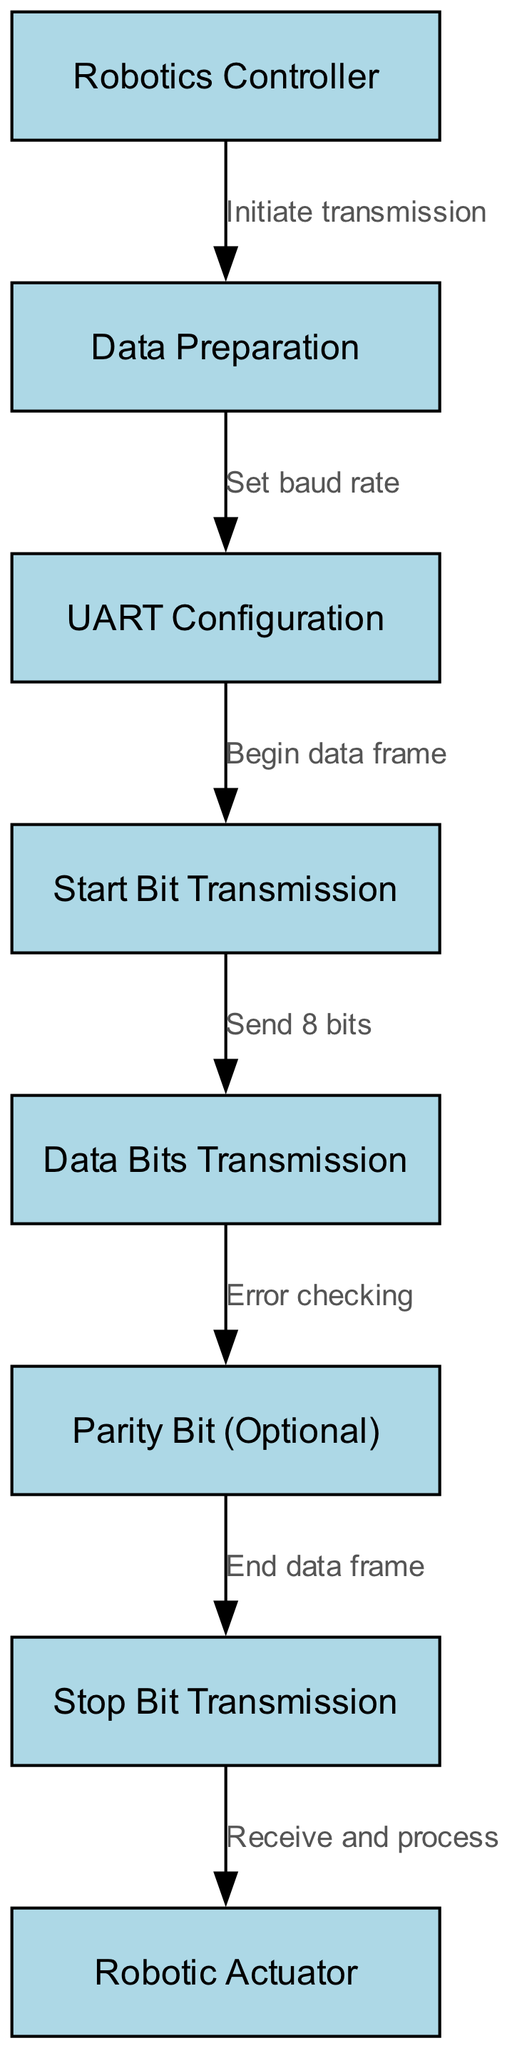What is the starting point of the transmission process? The starting point of the transmission process is the "Robotics Controller," which initiates the communication sequence.
Answer: Robotics Controller How many nodes are there in the diagram? There are a total of eight nodes represented in the diagram that outline the steps of the data transmission process.
Answer: Eight What does the "Data Preparation" node do? The "Data Preparation" node is responsible for setting the baud rate, which is essential for the transmission to occur effectively.
Answer: Set baud rate What follows after "Start Bit Transmission"? After "Start Bit Transmission," the next step is "Data Bits Transmission," where the actual data is sent in bits.
Answer: Data Bits Transmission What is the purpose of the "Parity Bit" node? The "Parity Bit" node is for "Error checking," helping to verify the integrity of transmitted data, though it is optional.
Answer: Error checking How does the flow proceed from "Stop Bit Transmission"? After "Stop Bit Transmission," the flow leads to the "Robotic Actuator," where the data received is processed.
Answer: Receive and process Which step comes directly after "UART Configuration"? The step that comes directly after "UART Configuration" is "Start Bit Transmission," signifying the beginning of the data frame.
Answer: Start Bit Transmission What is the role of the "Robotic Actuator"? The role of the "Robotic Actuator" is to receive the transmitted data and process it to take necessary actions based on that data.
Answer: Receive and process What type of communication does this diagram depict? This diagram depicts serial communication, specifically focusing on the flow of data transmission using UART.
Answer: Serial communication 